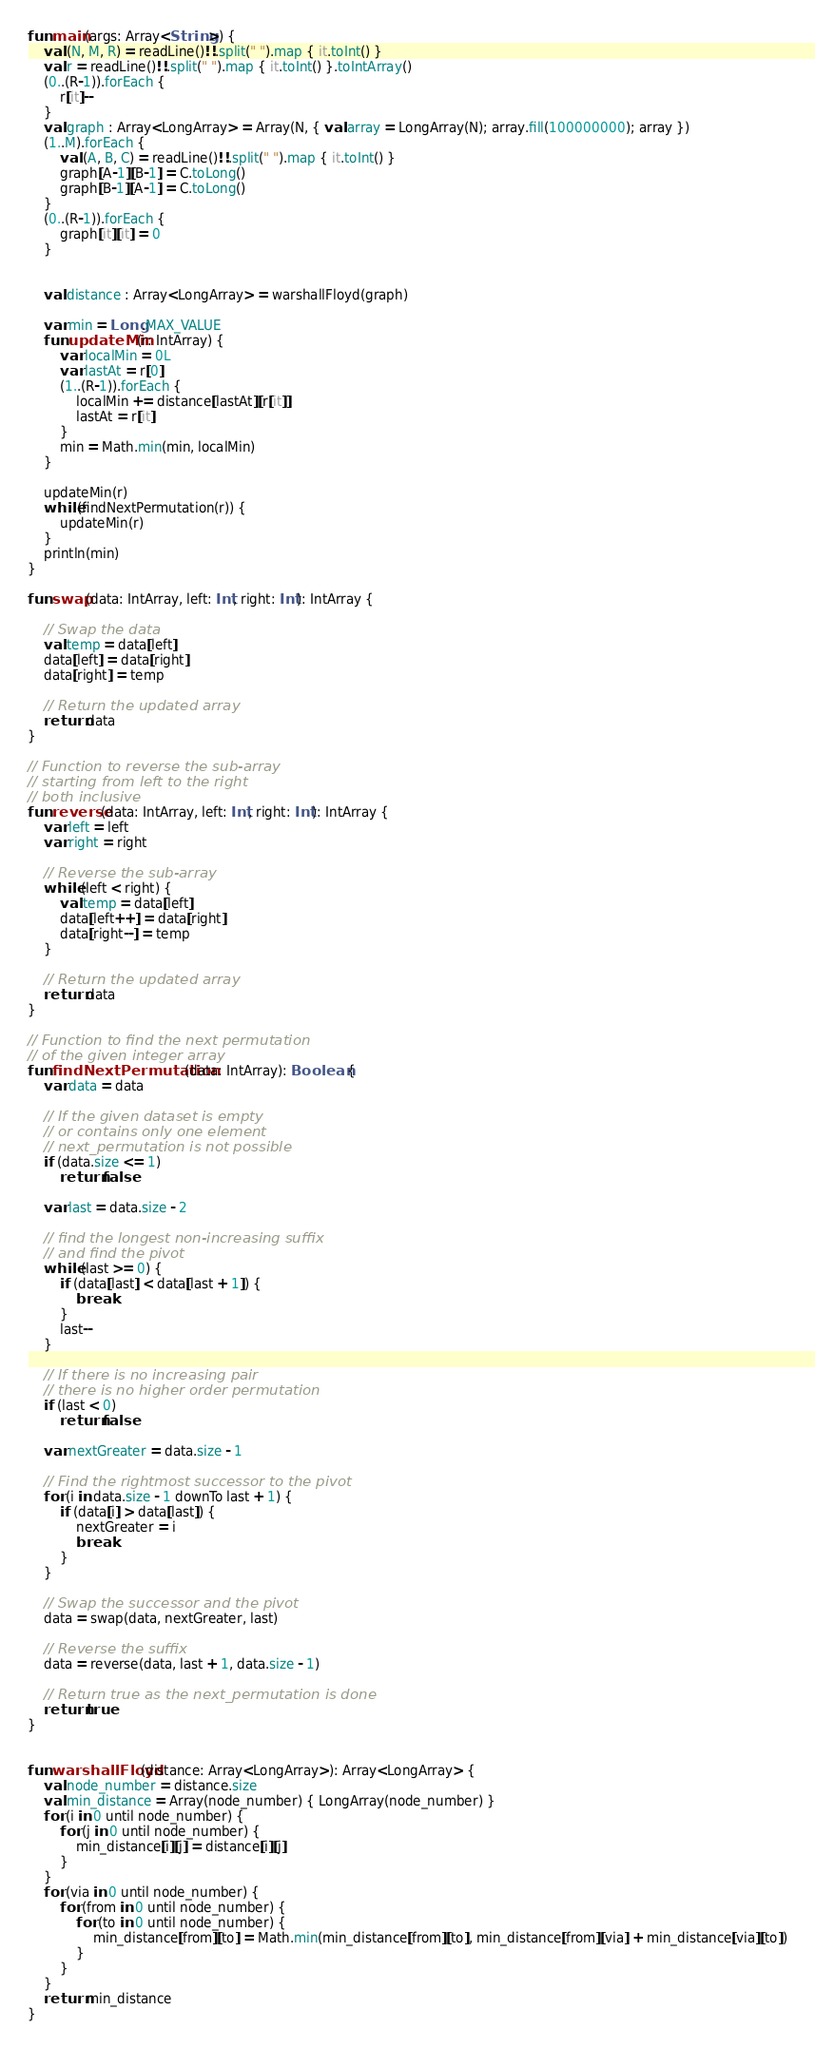<code> <loc_0><loc_0><loc_500><loc_500><_Kotlin_>fun main(args: Array<String>) {
    val (N, M, R) = readLine()!!.split(" ").map { it.toInt() }
    val r = readLine()!!.split(" ").map { it.toInt() }.toIntArray()
    (0..(R-1)).forEach {
        r[it]--
    }
    val graph : Array<LongArray> = Array(N, { val array = LongArray(N); array.fill(100000000); array })
    (1..M).forEach {
        val (A, B, C) = readLine()!!.split(" ").map { it.toInt() }
        graph[A-1][B-1] = C.toLong()
        graph[B-1][A-1] = C.toLong()
    }
    (0..(R-1)).forEach {
        graph[it][it] = 0
    }


    val distance : Array<LongArray> = warshallFloyd(graph)

    var min = Long.MAX_VALUE
    fun updateMin(r: IntArray) {
        var localMin = 0L
        var lastAt = r[0]
        (1..(R-1)).forEach {
            localMin += distance[lastAt][r[it]]
            lastAt = r[it]
        }
        min = Math.min(min, localMin)
    }

    updateMin(r)
    while(findNextPermutation(r)) {
        updateMin(r)
    }
    println(min)
}

fun swap(data: IntArray, left: Int, right: Int): IntArray {

    // Swap the data
    val temp = data[left]
    data[left] = data[right]
    data[right] = temp

    // Return the updated array
    return data
}

// Function to reverse the sub-array
// starting from left to the right
// both inclusive
fun reverse(data: IntArray, left: Int, right: Int): IntArray {
    var left = left
    var right = right

    // Reverse the sub-array
    while (left < right) {
        val temp = data[left]
        data[left++] = data[right]
        data[right--] = temp
    }

    // Return the updated array
    return data
}

// Function to find the next permutation
// of the given integer array
fun findNextPermutation(data: IntArray): Boolean {
    var data = data

    // If the given dataset is empty
    // or contains only one element
    // next_permutation is not possible
    if (data.size <= 1)
        return false

    var last = data.size - 2

    // find the longest non-increasing suffix
    // and find the pivot
    while (last >= 0) {
        if (data[last] < data[last + 1]) {
            break
        }
        last--
    }

    // If there is no increasing pair
    // there is no higher order permutation
    if (last < 0)
        return false

    var nextGreater = data.size - 1

    // Find the rightmost successor to the pivot
    for (i in data.size - 1 downTo last + 1) {
        if (data[i] > data[last]) {
            nextGreater = i
            break
        }
    }

    // Swap the successor and the pivot
    data = swap(data, nextGreater, last)

    // Reverse the suffix
    data = reverse(data, last + 1, data.size - 1)

    // Return true as the next_permutation is done
    return true
}


fun warshallFloyd(distance: Array<LongArray>): Array<LongArray> {
    val node_number = distance.size
    val min_distance = Array(node_number) { LongArray(node_number) }
    for (i in 0 until node_number) {
        for (j in 0 until node_number) {
            min_distance[i][j] = distance[i][j]
        }
    }
    for (via in 0 until node_number) {
        for (from in 0 until node_number) {
            for (to in 0 until node_number) {
                min_distance[from][to] = Math.min(min_distance[from][to], min_distance[from][via] + min_distance[via][to])
            }
        }
    }
    return min_distance
}</code> 